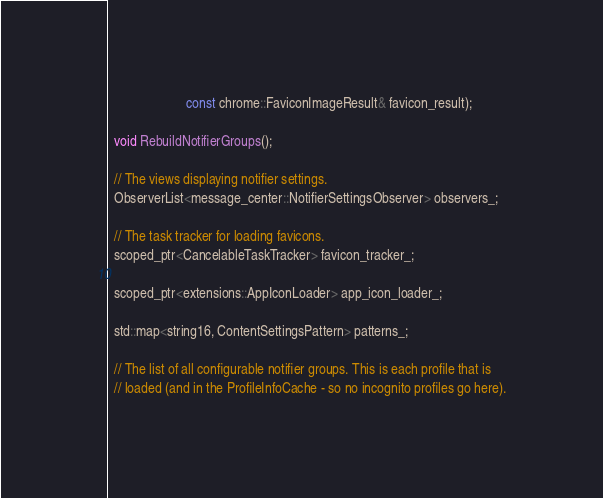Convert code to text. <code><loc_0><loc_0><loc_500><loc_500><_C_>                       const chrome::FaviconImageResult& favicon_result);

  void RebuildNotifierGroups();

  // The views displaying notifier settings.
  ObserverList<message_center::NotifierSettingsObserver> observers_;

  // The task tracker for loading favicons.
  scoped_ptr<CancelableTaskTracker> favicon_tracker_;

  scoped_ptr<extensions::AppIconLoader> app_icon_loader_;

  std::map<string16, ContentSettingsPattern> patterns_;

  // The list of all configurable notifier groups. This is each profile that is
  // loaded (and in the ProfileInfoCache - so no incognito profiles go here).</code> 